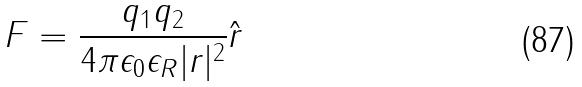<formula> <loc_0><loc_0><loc_500><loc_500>F = \frac { q _ { 1 } q _ { 2 } } { 4 \pi \epsilon _ { 0 } \epsilon _ { R } | r | ^ { 2 } } \hat { r }</formula> 